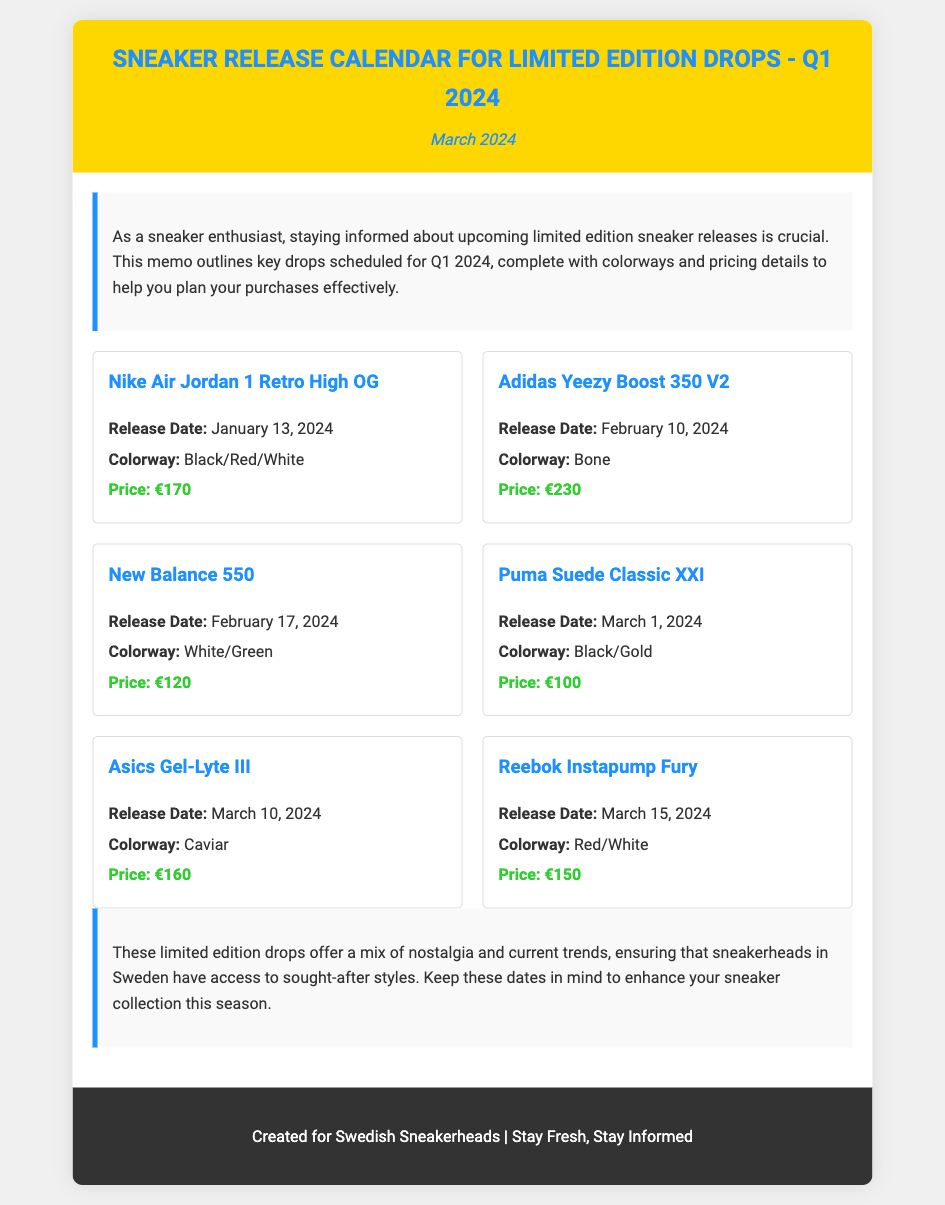What is the release date for the Nike Air Jordan 1 Retro High OG? The release date for the Nike Air Jordan 1 Retro High OG is listed in the document as January 13, 2024.
Answer: January 13, 2024 What colorway is the Adidas Yeezy Boost 350 V2? The colorway of the Adidas Yeezy Boost 350 V2 is specified in the document as Bone.
Answer: Bone What is the price of the New Balance 550? The price of the New Balance 550 can be found in the document, which states it is €120.
Answer: €120 How many sneakers are listed for release in March 2024? To find the number of sneakers listed for March, one would need to count the releases under that month, which adds up to three.
Answer: 3 Which sneaker is priced at €150? By examining the pricing details in the document, the sneaker priced at €150 is the Reebok Instapump Fury.
Answer: Reebok Instapump Fury What is the title of the memo? The title is provided at the top of the document as "Sneaker Release Calendar for Limited Edition Drops - Q1 2024."
Answer: Sneaker Release Calendar for Limited Edition Drops - Q1 2024 What colorway do the Puma Suede Classic XXI come in? The document includes the colorway for the Puma Suede Classic XXI as Black/Gold.
Answer: Black/Gold What type of memo is this? The content and structure indicate that this is a memo outlining sneaker release dates and details.
Answer: A memo 